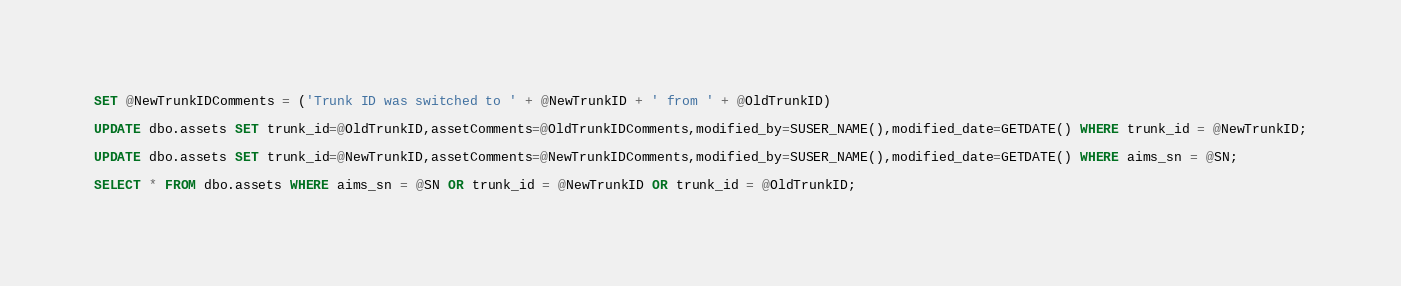<code> <loc_0><loc_0><loc_500><loc_500><_SQL_>SET @NewTrunkIDComments = ('Trunk ID was switched to ' + @NewTrunkID + ' from ' + @OldTrunkID)

UPDATE dbo.assets SET trunk_id=@OldTrunkID,assetComments=@OldTrunkIDComments,modified_by=SUSER_NAME(),modified_date=GETDATE() WHERE trunk_id = @NewTrunkID;

UPDATE dbo.assets SET trunk_id=@NewTrunkID,assetComments=@NewTrunkIDComments,modified_by=SUSER_NAME(),modified_date=GETDATE() WHERE aims_sn = @SN;

SELECT * FROM dbo.assets WHERE aims_sn = @SN OR trunk_id = @NewTrunkID OR trunk_id = @OldTrunkID;
</code> 